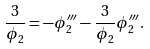Convert formula to latex. <formula><loc_0><loc_0><loc_500><loc_500>\frac { 3 } { \phi _ { 2 } } = - \phi _ { 2 } ^ { \prime \prime \prime } - \frac { 3 } { \phi _ { 2 } } \phi _ { 2 } ^ { \prime \prime \prime } .</formula> 